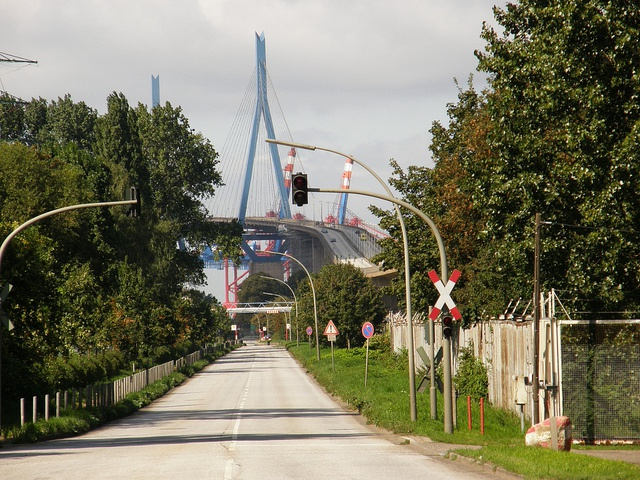Describe the objects in this image and their specific colors. I can see traffic light in lightgray, black, and gray tones, traffic light in lightgray, black, gray, and darkgreen tones, traffic light in lightgray, black, gray, and maroon tones, car in lightgray, olive, and gray tones, and car in lightgray, gray, and black tones in this image. 